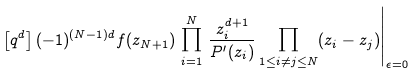<formula> <loc_0><loc_0><loc_500><loc_500>\left [ q ^ { d } \right ] ( - 1 ) ^ { ( N - 1 ) d } f ( z _ { N + 1 } ) \, \prod _ { i = 1 } ^ { N } \, \frac { z _ { i } ^ { d + 1 } } { P ^ { \prime } ( z _ { i } ) } \prod _ { 1 \leq i \neq j \leq N } ( z _ { i } - z _ { j } ) \Big { | } _ { \epsilon = 0 }</formula> 